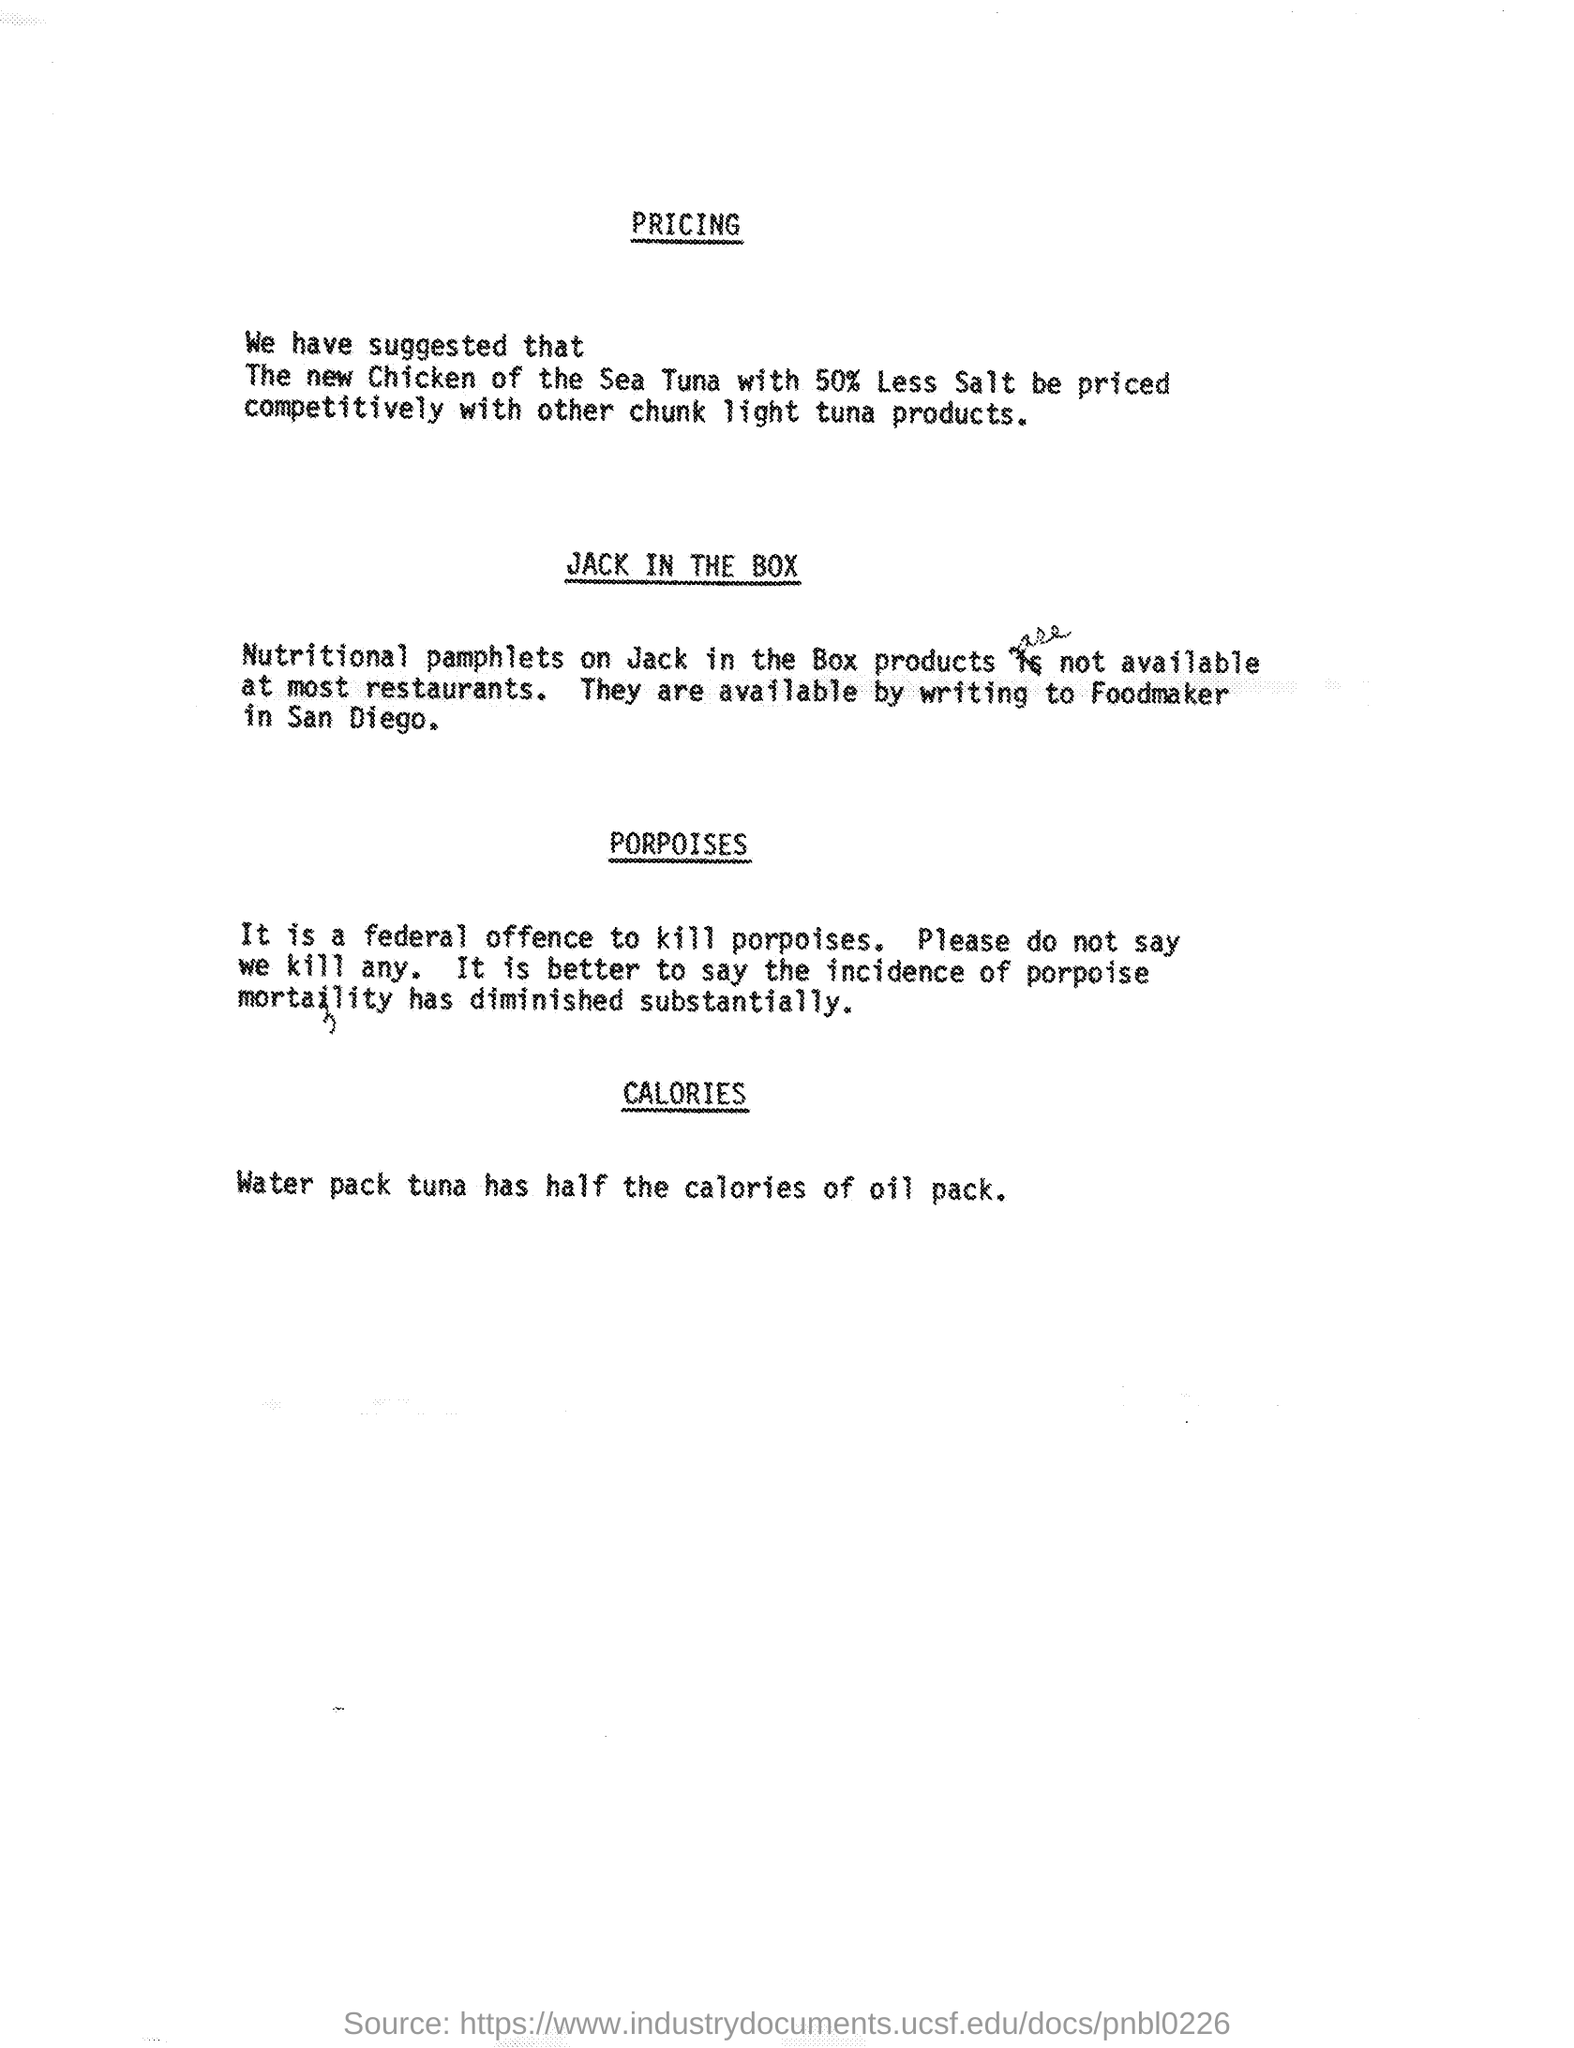Specify some key components in this picture. The act of killing porpoises is considered a federal offense. 